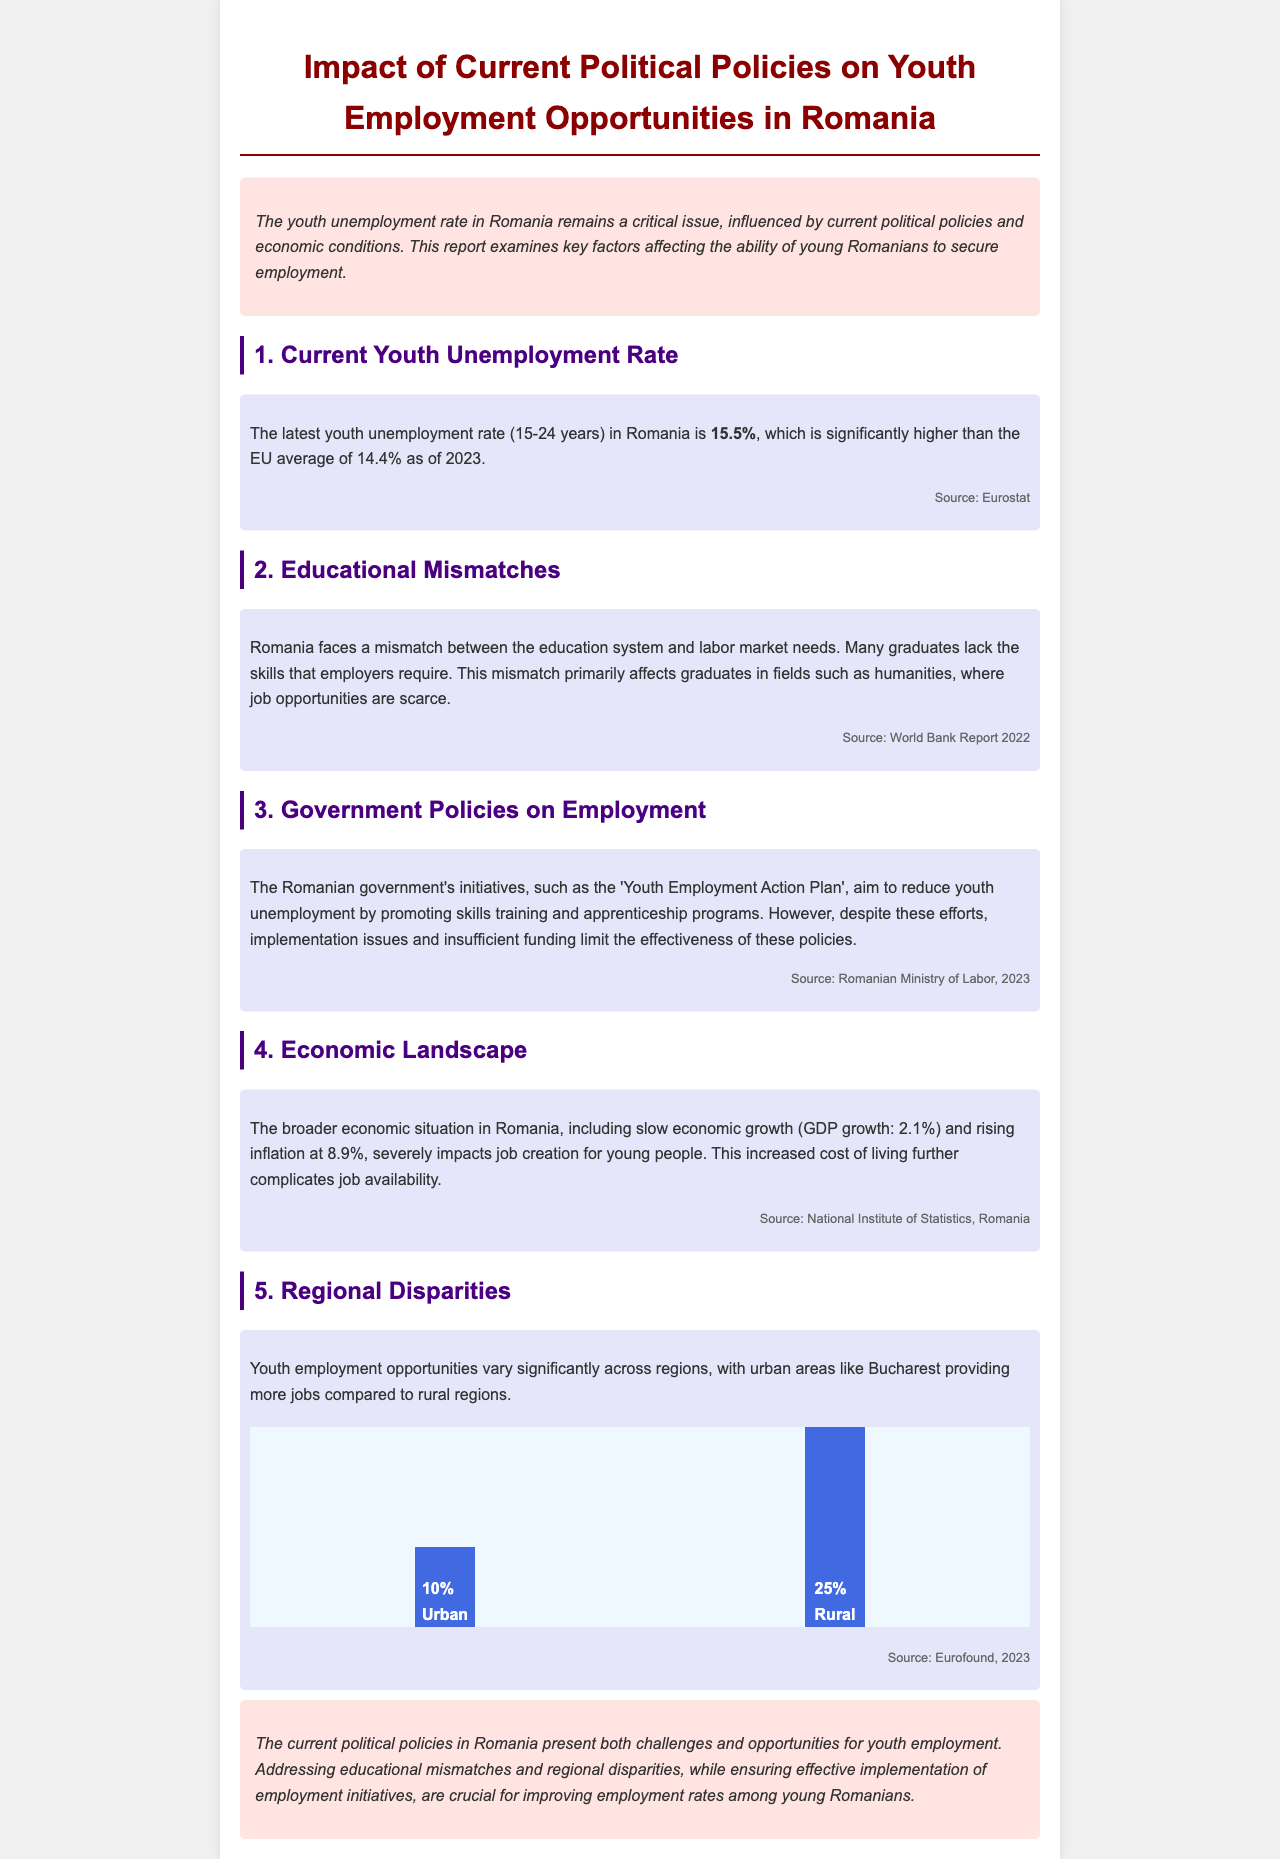What is the youth unemployment rate in Romania? The document states that the latest youth unemployment rate (15-24 years) in Romania is 15.5%.
Answer: 15.5% What is the EU average youth unemployment rate? According to the document, the EU average youth unemployment rate is 14.4% as of 2023.
Answer: 14.4% What is a key issue affecting graduates in Romania? The document mentions that many graduates lack the skills that employers require, primarily affecting fields such as humanities.
Answer: Skills mismatch What initiatives are included in the 'Youth Employment Action Plan'? The document refers to promoting skills training and apprenticeship programs as part of the initiatives.
Answer: Skills training and apprenticeship programs What is the GDP growth rate mentioned in the report? The document cites a slow economic growth rate of 2.1% for Romania.
Answer: 2.1% How much is the inflation rate in Romania? The inflation rate mentioned in the document is 8.9%.
Answer: 8.9% What are the employment opportunities between urban and rural areas? The document states that youth employment opportunities vary significantly, with urban areas like Bucharest providing more jobs compared to rural regions.
Answer: Urban vs. Rural disparity What are two major factors complicating job availability for youth in Romania? The document indicates that slow economic growth and rising inflation severely impact job creation for young people.
Answer: Economic growth and inflation What does the conclusion suggest is crucial for improving employment rates? The conclusion emphasizes that addressing educational mismatches and regional disparities is crucial for improving employment rates among young Romanians.
Answer: Addressing educational mismatches and regional disparities 